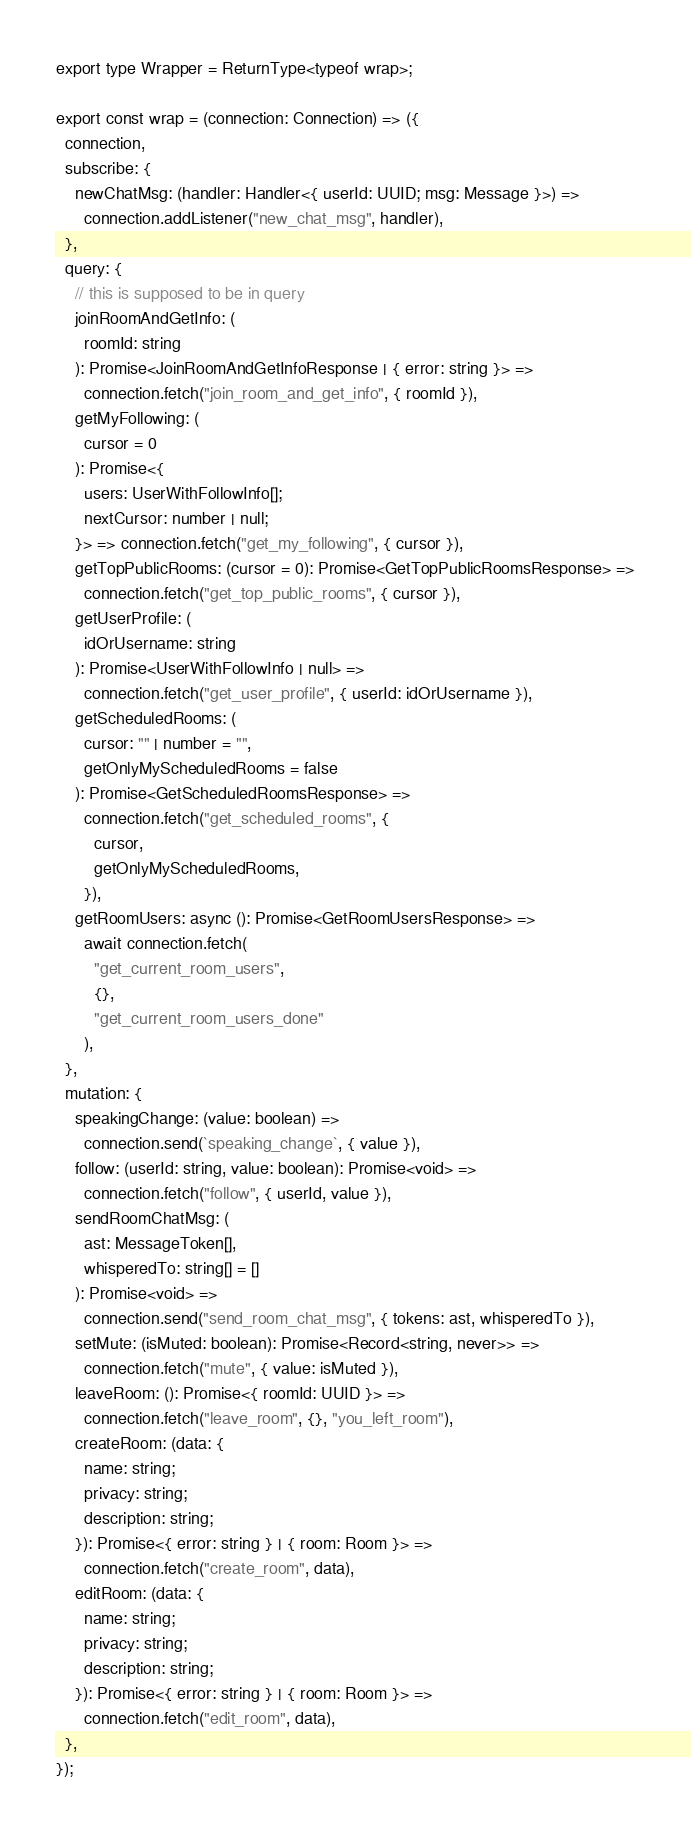Convert code to text. <code><loc_0><loc_0><loc_500><loc_500><_TypeScript_>
export type Wrapper = ReturnType<typeof wrap>;

export const wrap = (connection: Connection) => ({
  connection,
  subscribe: {
    newChatMsg: (handler: Handler<{ userId: UUID; msg: Message }>) =>
      connection.addListener("new_chat_msg", handler),
  },
  query: {
    // this is supposed to be in query
    joinRoomAndGetInfo: (
      roomId: string
    ): Promise<JoinRoomAndGetInfoResponse | { error: string }> =>
      connection.fetch("join_room_and_get_info", { roomId }),
    getMyFollowing: (
      cursor = 0
    ): Promise<{
      users: UserWithFollowInfo[];
      nextCursor: number | null;
    }> => connection.fetch("get_my_following", { cursor }),
    getTopPublicRooms: (cursor = 0): Promise<GetTopPublicRoomsResponse> =>
      connection.fetch("get_top_public_rooms", { cursor }),
    getUserProfile: (
      idOrUsername: string
    ): Promise<UserWithFollowInfo | null> =>
      connection.fetch("get_user_profile", { userId: idOrUsername }),
    getScheduledRooms: (
      cursor: "" | number = "",
      getOnlyMyScheduledRooms = false
    ): Promise<GetScheduledRoomsResponse> =>
      connection.fetch("get_scheduled_rooms", {
        cursor,
        getOnlyMyScheduledRooms,
      }),
    getRoomUsers: async (): Promise<GetRoomUsersResponse> =>
      await connection.fetch(
        "get_current_room_users",
        {},
        "get_current_room_users_done"
      ),
  },
  mutation: {
    speakingChange: (value: boolean) =>
      connection.send(`speaking_change`, { value }),
    follow: (userId: string, value: boolean): Promise<void> =>
      connection.fetch("follow", { userId, value }),
    sendRoomChatMsg: (
      ast: MessageToken[],
      whisperedTo: string[] = []
    ): Promise<void> =>
      connection.send("send_room_chat_msg", { tokens: ast, whisperedTo }),
    setMute: (isMuted: boolean): Promise<Record<string, never>> =>
      connection.fetch("mute", { value: isMuted }),
    leaveRoom: (): Promise<{ roomId: UUID }> =>
      connection.fetch("leave_room", {}, "you_left_room"),
    createRoom: (data: {
      name: string;
      privacy: string;
      description: string;
    }): Promise<{ error: string } | { room: Room }> =>
      connection.fetch("create_room", data),
    editRoom: (data: {
      name: string;
      privacy: string;
      description: string;
    }): Promise<{ error: string } | { room: Room }> =>
      connection.fetch("edit_room", data),
  },
});
</code> 